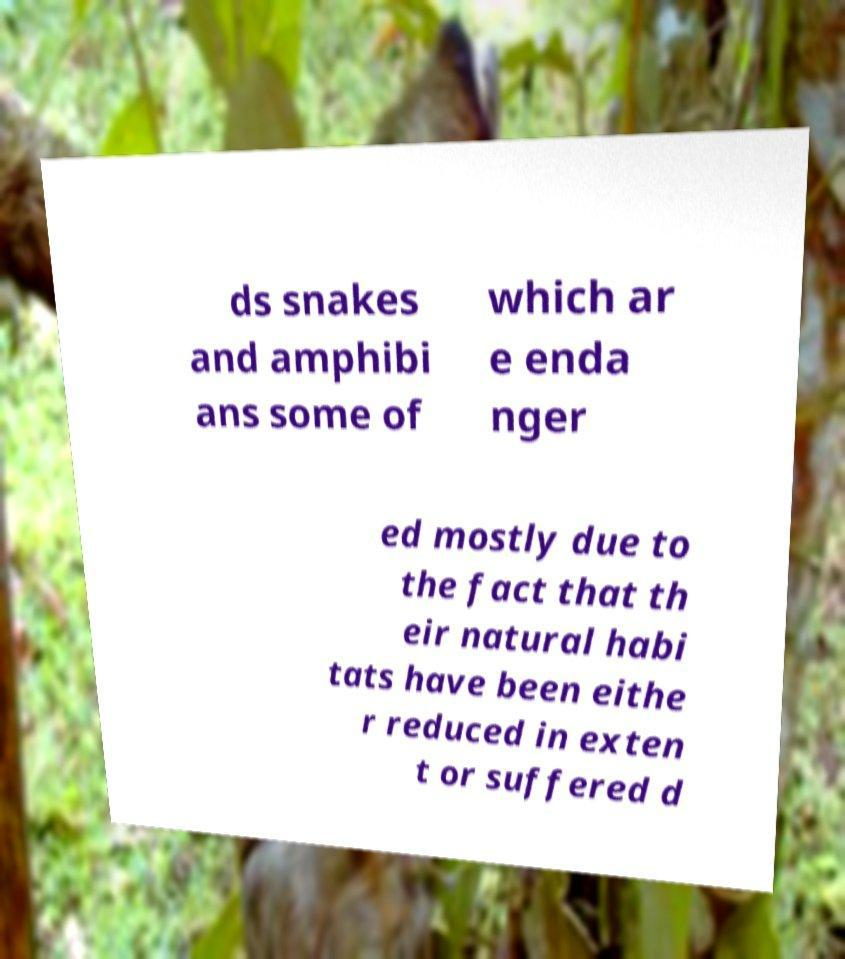Please read and relay the text visible in this image. What does it say? ds snakes and amphibi ans some of which ar e enda nger ed mostly due to the fact that th eir natural habi tats have been eithe r reduced in exten t or suffered d 